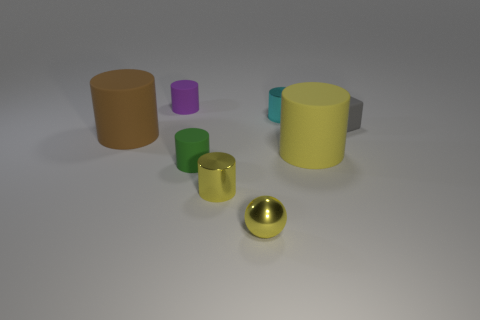Subtract all brown rubber cylinders. How many cylinders are left? 5 Subtract all gray cubes. How many yellow cylinders are left? 2 Subtract all purple cylinders. How many cylinders are left? 5 Subtract 2 cylinders. How many cylinders are left? 4 Add 1 brown matte cylinders. How many objects exist? 9 Subtract all spheres. How many objects are left? 7 Subtract 0 blue cylinders. How many objects are left? 8 Subtract all purple cylinders. Subtract all green blocks. How many cylinders are left? 5 Subtract all brown metal balls. Subtract all large yellow cylinders. How many objects are left? 7 Add 4 tiny metallic balls. How many tiny metallic balls are left? 5 